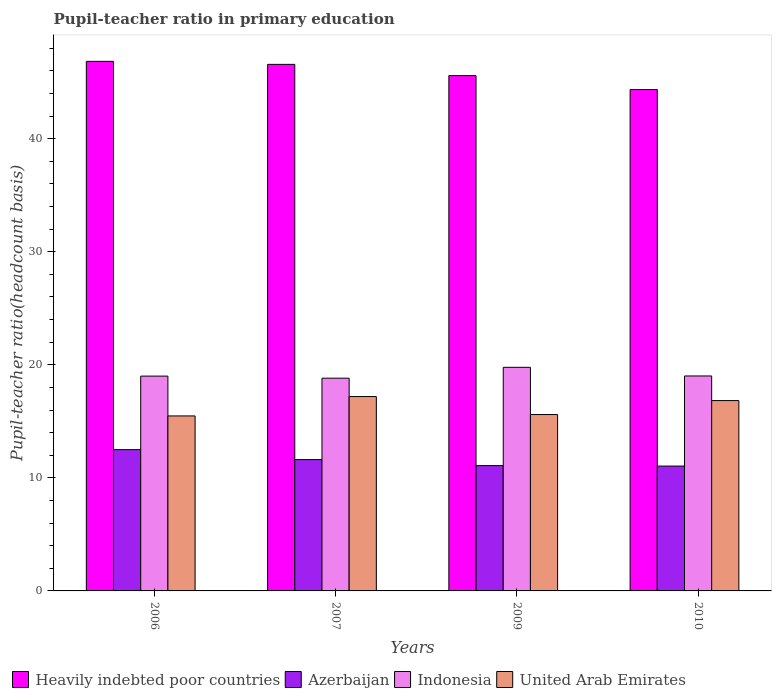How many groups of bars are there?
Provide a succinct answer. 4. Are the number of bars per tick equal to the number of legend labels?
Your answer should be very brief. Yes. In how many cases, is the number of bars for a given year not equal to the number of legend labels?
Give a very brief answer. 0. What is the pupil-teacher ratio in primary education in Azerbaijan in 2006?
Offer a very short reply. 12.5. Across all years, what is the maximum pupil-teacher ratio in primary education in Heavily indebted poor countries?
Give a very brief answer. 46.84. Across all years, what is the minimum pupil-teacher ratio in primary education in Heavily indebted poor countries?
Your answer should be compact. 44.35. In which year was the pupil-teacher ratio in primary education in Azerbaijan minimum?
Make the answer very short. 2010. What is the total pupil-teacher ratio in primary education in Azerbaijan in the graph?
Offer a terse response. 46.24. What is the difference between the pupil-teacher ratio in primary education in United Arab Emirates in 2007 and that in 2009?
Ensure brevity in your answer.  1.59. What is the difference between the pupil-teacher ratio in primary education in United Arab Emirates in 2009 and the pupil-teacher ratio in primary education in Heavily indebted poor countries in 2006?
Your answer should be very brief. -31.24. What is the average pupil-teacher ratio in primary education in Indonesia per year?
Make the answer very short. 19.15. In the year 2006, what is the difference between the pupil-teacher ratio in primary education in Indonesia and pupil-teacher ratio in primary education in Azerbaijan?
Provide a succinct answer. 6.5. What is the ratio of the pupil-teacher ratio in primary education in United Arab Emirates in 2006 to that in 2007?
Your answer should be compact. 0.9. What is the difference between the highest and the second highest pupil-teacher ratio in primary education in Heavily indebted poor countries?
Provide a short and direct response. 0.27. What is the difference between the highest and the lowest pupil-teacher ratio in primary education in United Arab Emirates?
Offer a very short reply. 1.71. Is the sum of the pupil-teacher ratio in primary education in Indonesia in 2007 and 2010 greater than the maximum pupil-teacher ratio in primary education in Heavily indebted poor countries across all years?
Give a very brief answer. No. What does the 3rd bar from the left in 2006 represents?
Provide a short and direct response. Indonesia. What does the 4th bar from the right in 2006 represents?
Give a very brief answer. Heavily indebted poor countries. Is it the case that in every year, the sum of the pupil-teacher ratio in primary education in Azerbaijan and pupil-teacher ratio in primary education in Indonesia is greater than the pupil-teacher ratio in primary education in Heavily indebted poor countries?
Ensure brevity in your answer.  No. How many bars are there?
Keep it short and to the point. 16. What is the difference between two consecutive major ticks on the Y-axis?
Provide a short and direct response. 10. Does the graph contain grids?
Make the answer very short. No. How many legend labels are there?
Your answer should be compact. 4. How are the legend labels stacked?
Offer a very short reply. Horizontal. What is the title of the graph?
Make the answer very short. Pupil-teacher ratio in primary education. Does "Mauritania" appear as one of the legend labels in the graph?
Keep it short and to the point. No. What is the label or title of the Y-axis?
Offer a very short reply. Pupil-teacher ratio(headcount basis). What is the Pupil-teacher ratio(headcount basis) of Heavily indebted poor countries in 2006?
Ensure brevity in your answer.  46.84. What is the Pupil-teacher ratio(headcount basis) of Azerbaijan in 2006?
Your answer should be very brief. 12.5. What is the Pupil-teacher ratio(headcount basis) of Indonesia in 2006?
Offer a terse response. 19. What is the Pupil-teacher ratio(headcount basis) of United Arab Emirates in 2006?
Keep it short and to the point. 15.48. What is the Pupil-teacher ratio(headcount basis) in Heavily indebted poor countries in 2007?
Offer a terse response. 46.57. What is the Pupil-teacher ratio(headcount basis) of Azerbaijan in 2007?
Your response must be concise. 11.62. What is the Pupil-teacher ratio(headcount basis) in Indonesia in 2007?
Provide a succinct answer. 18.82. What is the Pupil-teacher ratio(headcount basis) of United Arab Emirates in 2007?
Provide a succinct answer. 17.19. What is the Pupil-teacher ratio(headcount basis) of Heavily indebted poor countries in 2009?
Make the answer very short. 45.58. What is the Pupil-teacher ratio(headcount basis) of Azerbaijan in 2009?
Provide a succinct answer. 11.08. What is the Pupil-teacher ratio(headcount basis) of Indonesia in 2009?
Your answer should be very brief. 19.78. What is the Pupil-teacher ratio(headcount basis) in United Arab Emirates in 2009?
Keep it short and to the point. 15.6. What is the Pupil-teacher ratio(headcount basis) in Heavily indebted poor countries in 2010?
Make the answer very short. 44.35. What is the Pupil-teacher ratio(headcount basis) in Azerbaijan in 2010?
Provide a short and direct response. 11.04. What is the Pupil-teacher ratio(headcount basis) of Indonesia in 2010?
Make the answer very short. 19.01. What is the Pupil-teacher ratio(headcount basis) of United Arab Emirates in 2010?
Provide a succinct answer. 16.83. Across all years, what is the maximum Pupil-teacher ratio(headcount basis) of Heavily indebted poor countries?
Your answer should be compact. 46.84. Across all years, what is the maximum Pupil-teacher ratio(headcount basis) in Azerbaijan?
Provide a short and direct response. 12.5. Across all years, what is the maximum Pupil-teacher ratio(headcount basis) in Indonesia?
Keep it short and to the point. 19.78. Across all years, what is the maximum Pupil-teacher ratio(headcount basis) of United Arab Emirates?
Give a very brief answer. 17.19. Across all years, what is the minimum Pupil-teacher ratio(headcount basis) of Heavily indebted poor countries?
Provide a short and direct response. 44.35. Across all years, what is the minimum Pupil-teacher ratio(headcount basis) of Azerbaijan?
Keep it short and to the point. 11.04. Across all years, what is the minimum Pupil-teacher ratio(headcount basis) of Indonesia?
Provide a succinct answer. 18.82. Across all years, what is the minimum Pupil-teacher ratio(headcount basis) in United Arab Emirates?
Your response must be concise. 15.48. What is the total Pupil-teacher ratio(headcount basis) of Heavily indebted poor countries in the graph?
Your answer should be very brief. 183.33. What is the total Pupil-teacher ratio(headcount basis) in Azerbaijan in the graph?
Make the answer very short. 46.24. What is the total Pupil-teacher ratio(headcount basis) in Indonesia in the graph?
Offer a terse response. 76.6. What is the total Pupil-teacher ratio(headcount basis) in United Arab Emirates in the graph?
Your response must be concise. 65.1. What is the difference between the Pupil-teacher ratio(headcount basis) of Heavily indebted poor countries in 2006 and that in 2007?
Provide a succinct answer. 0.27. What is the difference between the Pupil-teacher ratio(headcount basis) of Azerbaijan in 2006 and that in 2007?
Give a very brief answer. 0.88. What is the difference between the Pupil-teacher ratio(headcount basis) of Indonesia in 2006 and that in 2007?
Make the answer very short. 0.18. What is the difference between the Pupil-teacher ratio(headcount basis) in United Arab Emirates in 2006 and that in 2007?
Make the answer very short. -1.71. What is the difference between the Pupil-teacher ratio(headcount basis) of Heavily indebted poor countries in 2006 and that in 2009?
Provide a succinct answer. 1.26. What is the difference between the Pupil-teacher ratio(headcount basis) in Azerbaijan in 2006 and that in 2009?
Offer a terse response. 1.41. What is the difference between the Pupil-teacher ratio(headcount basis) of Indonesia in 2006 and that in 2009?
Offer a very short reply. -0.78. What is the difference between the Pupil-teacher ratio(headcount basis) in United Arab Emirates in 2006 and that in 2009?
Provide a succinct answer. -0.12. What is the difference between the Pupil-teacher ratio(headcount basis) in Heavily indebted poor countries in 2006 and that in 2010?
Provide a succinct answer. 2.49. What is the difference between the Pupil-teacher ratio(headcount basis) in Azerbaijan in 2006 and that in 2010?
Offer a terse response. 1.45. What is the difference between the Pupil-teacher ratio(headcount basis) in Indonesia in 2006 and that in 2010?
Offer a very short reply. -0.01. What is the difference between the Pupil-teacher ratio(headcount basis) in United Arab Emirates in 2006 and that in 2010?
Your answer should be very brief. -1.36. What is the difference between the Pupil-teacher ratio(headcount basis) of Azerbaijan in 2007 and that in 2009?
Your answer should be very brief. 0.53. What is the difference between the Pupil-teacher ratio(headcount basis) in Indonesia in 2007 and that in 2009?
Provide a short and direct response. -0.96. What is the difference between the Pupil-teacher ratio(headcount basis) in United Arab Emirates in 2007 and that in 2009?
Offer a terse response. 1.59. What is the difference between the Pupil-teacher ratio(headcount basis) in Heavily indebted poor countries in 2007 and that in 2010?
Your answer should be very brief. 2.23. What is the difference between the Pupil-teacher ratio(headcount basis) of Azerbaijan in 2007 and that in 2010?
Provide a succinct answer. 0.57. What is the difference between the Pupil-teacher ratio(headcount basis) in Indonesia in 2007 and that in 2010?
Your answer should be compact. -0.2. What is the difference between the Pupil-teacher ratio(headcount basis) of United Arab Emirates in 2007 and that in 2010?
Provide a succinct answer. 0.36. What is the difference between the Pupil-teacher ratio(headcount basis) in Heavily indebted poor countries in 2009 and that in 2010?
Offer a very short reply. 1.23. What is the difference between the Pupil-teacher ratio(headcount basis) in Azerbaijan in 2009 and that in 2010?
Offer a very short reply. 0.04. What is the difference between the Pupil-teacher ratio(headcount basis) in Indonesia in 2009 and that in 2010?
Keep it short and to the point. 0.76. What is the difference between the Pupil-teacher ratio(headcount basis) of United Arab Emirates in 2009 and that in 2010?
Offer a very short reply. -1.23. What is the difference between the Pupil-teacher ratio(headcount basis) of Heavily indebted poor countries in 2006 and the Pupil-teacher ratio(headcount basis) of Azerbaijan in 2007?
Offer a very short reply. 35.22. What is the difference between the Pupil-teacher ratio(headcount basis) in Heavily indebted poor countries in 2006 and the Pupil-teacher ratio(headcount basis) in Indonesia in 2007?
Keep it short and to the point. 28.02. What is the difference between the Pupil-teacher ratio(headcount basis) in Heavily indebted poor countries in 2006 and the Pupil-teacher ratio(headcount basis) in United Arab Emirates in 2007?
Your answer should be very brief. 29.65. What is the difference between the Pupil-teacher ratio(headcount basis) of Azerbaijan in 2006 and the Pupil-teacher ratio(headcount basis) of Indonesia in 2007?
Give a very brief answer. -6.32. What is the difference between the Pupil-teacher ratio(headcount basis) of Azerbaijan in 2006 and the Pupil-teacher ratio(headcount basis) of United Arab Emirates in 2007?
Your answer should be very brief. -4.69. What is the difference between the Pupil-teacher ratio(headcount basis) of Indonesia in 2006 and the Pupil-teacher ratio(headcount basis) of United Arab Emirates in 2007?
Keep it short and to the point. 1.81. What is the difference between the Pupil-teacher ratio(headcount basis) of Heavily indebted poor countries in 2006 and the Pupil-teacher ratio(headcount basis) of Azerbaijan in 2009?
Provide a succinct answer. 35.75. What is the difference between the Pupil-teacher ratio(headcount basis) of Heavily indebted poor countries in 2006 and the Pupil-teacher ratio(headcount basis) of Indonesia in 2009?
Provide a short and direct response. 27.06. What is the difference between the Pupil-teacher ratio(headcount basis) of Heavily indebted poor countries in 2006 and the Pupil-teacher ratio(headcount basis) of United Arab Emirates in 2009?
Offer a terse response. 31.24. What is the difference between the Pupil-teacher ratio(headcount basis) in Azerbaijan in 2006 and the Pupil-teacher ratio(headcount basis) in Indonesia in 2009?
Give a very brief answer. -7.28. What is the difference between the Pupil-teacher ratio(headcount basis) of Azerbaijan in 2006 and the Pupil-teacher ratio(headcount basis) of United Arab Emirates in 2009?
Offer a very short reply. -3.1. What is the difference between the Pupil-teacher ratio(headcount basis) of Indonesia in 2006 and the Pupil-teacher ratio(headcount basis) of United Arab Emirates in 2009?
Ensure brevity in your answer.  3.4. What is the difference between the Pupil-teacher ratio(headcount basis) in Heavily indebted poor countries in 2006 and the Pupil-teacher ratio(headcount basis) in Azerbaijan in 2010?
Ensure brevity in your answer.  35.8. What is the difference between the Pupil-teacher ratio(headcount basis) of Heavily indebted poor countries in 2006 and the Pupil-teacher ratio(headcount basis) of Indonesia in 2010?
Ensure brevity in your answer.  27.83. What is the difference between the Pupil-teacher ratio(headcount basis) of Heavily indebted poor countries in 2006 and the Pupil-teacher ratio(headcount basis) of United Arab Emirates in 2010?
Offer a terse response. 30. What is the difference between the Pupil-teacher ratio(headcount basis) in Azerbaijan in 2006 and the Pupil-teacher ratio(headcount basis) in Indonesia in 2010?
Provide a succinct answer. -6.52. What is the difference between the Pupil-teacher ratio(headcount basis) in Azerbaijan in 2006 and the Pupil-teacher ratio(headcount basis) in United Arab Emirates in 2010?
Make the answer very short. -4.34. What is the difference between the Pupil-teacher ratio(headcount basis) of Indonesia in 2006 and the Pupil-teacher ratio(headcount basis) of United Arab Emirates in 2010?
Offer a terse response. 2.17. What is the difference between the Pupil-teacher ratio(headcount basis) of Heavily indebted poor countries in 2007 and the Pupil-teacher ratio(headcount basis) of Azerbaijan in 2009?
Your answer should be compact. 35.49. What is the difference between the Pupil-teacher ratio(headcount basis) in Heavily indebted poor countries in 2007 and the Pupil-teacher ratio(headcount basis) in Indonesia in 2009?
Offer a terse response. 26.79. What is the difference between the Pupil-teacher ratio(headcount basis) in Heavily indebted poor countries in 2007 and the Pupil-teacher ratio(headcount basis) in United Arab Emirates in 2009?
Your answer should be very brief. 30.97. What is the difference between the Pupil-teacher ratio(headcount basis) in Azerbaijan in 2007 and the Pupil-teacher ratio(headcount basis) in Indonesia in 2009?
Offer a very short reply. -8.16. What is the difference between the Pupil-teacher ratio(headcount basis) in Azerbaijan in 2007 and the Pupil-teacher ratio(headcount basis) in United Arab Emirates in 2009?
Your answer should be compact. -3.98. What is the difference between the Pupil-teacher ratio(headcount basis) of Indonesia in 2007 and the Pupil-teacher ratio(headcount basis) of United Arab Emirates in 2009?
Ensure brevity in your answer.  3.22. What is the difference between the Pupil-teacher ratio(headcount basis) of Heavily indebted poor countries in 2007 and the Pupil-teacher ratio(headcount basis) of Azerbaijan in 2010?
Your response must be concise. 35.53. What is the difference between the Pupil-teacher ratio(headcount basis) in Heavily indebted poor countries in 2007 and the Pupil-teacher ratio(headcount basis) in Indonesia in 2010?
Give a very brief answer. 27.56. What is the difference between the Pupil-teacher ratio(headcount basis) of Heavily indebted poor countries in 2007 and the Pupil-teacher ratio(headcount basis) of United Arab Emirates in 2010?
Provide a short and direct response. 29.74. What is the difference between the Pupil-teacher ratio(headcount basis) of Azerbaijan in 2007 and the Pupil-teacher ratio(headcount basis) of Indonesia in 2010?
Provide a succinct answer. -7.4. What is the difference between the Pupil-teacher ratio(headcount basis) in Azerbaijan in 2007 and the Pupil-teacher ratio(headcount basis) in United Arab Emirates in 2010?
Keep it short and to the point. -5.22. What is the difference between the Pupil-teacher ratio(headcount basis) of Indonesia in 2007 and the Pupil-teacher ratio(headcount basis) of United Arab Emirates in 2010?
Offer a very short reply. 1.98. What is the difference between the Pupil-teacher ratio(headcount basis) in Heavily indebted poor countries in 2009 and the Pupil-teacher ratio(headcount basis) in Azerbaijan in 2010?
Your answer should be compact. 34.53. What is the difference between the Pupil-teacher ratio(headcount basis) in Heavily indebted poor countries in 2009 and the Pupil-teacher ratio(headcount basis) in Indonesia in 2010?
Your response must be concise. 26.56. What is the difference between the Pupil-teacher ratio(headcount basis) in Heavily indebted poor countries in 2009 and the Pupil-teacher ratio(headcount basis) in United Arab Emirates in 2010?
Your answer should be compact. 28.74. What is the difference between the Pupil-teacher ratio(headcount basis) in Azerbaijan in 2009 and the Pupil-teacher ratio(headcount basis) in Indonesia in 2010?
Ensure brevity in your answer.  -7.93. What is the difference between the Pupil-teacher ratio(headcount basis) in Azerbaijan in 2009 and the Pupil-teacher ratio(headcount basis) in United Arab Emirates in 2010?
Provide a succinct answer. -5.75. What is the difference between the Pupil-teacher ratio(headcount basis) in Indonesia in 2009 and the Pupil-teacher ratio(headcount basis) in United Arab Emirates in 2010?
Provide a succinct answer. 2.94. What is the average Pupil-teacher ratio(headcount basis) of Heavily indebted poor countries per year?
Offer a very short reply. 45.83. What is the average Pupil-teacher ratio(headcount basis) of Azerbaijan per year?
Your response must be concise. 11.56. What is the average Pupil-teacher ratio(headcount basis) in Indonesia per year?
Offer a terse response. 19.15. What is the average Pupil-teacher ratio(headcount basis) of United Arab Emirates per year?
Your response must be concise. 16.28. In the year 2006, what is the difference between the Pupil-teacher ratio(headcount basis) in Heavily indebted poor countries and Pupil-teacher ratio(headcount basis) in Azerbaijan?
Provide a short and direct response. 34.34. In the year 2006, what is the difference between the Pupil-teacher ratio(headcount basis) in Heavily indebted poor countries and Pupil-teacher ratio(headcount basis) in Indonesia?
Offer a terse response. 27.84. In the year 2006, what is the difference between the Pupil-teacher ratio(headcount basis) in Heavily indebted poor countries and Pupil-teacher ratio(headcount basis) in United Arab Emirates?
Give a very brief answer. 31.36. In the year 2006, what is the difference between the Pupil-teacher ratio(headcount basis) of Azerbaijan and Pupil-teacher ratio(headcount basis) of Indonesia?
Give a very brief answer. -6.5. In the year 2006, what is the difference between the Pupil-teacher ratio(headcount basis) in Azerbaijan and Pupil-teacher ratio(headcount basis) in United Arab Emirates?
Ensure brevity in your answer.  -2.98. In the year 2006, what is the difference between the Pupil-teacher ratio(headcount basis) in Indonesia and Pupil-teacher ratio(headcount basis) in United Arab Emirates?
Your answer should be compact. 3.52. In the year 2007, what is the difference between the Pupil-teacher ratio(headcount basis) of Heavily indebted poor countries and Pupil-teacher ratio(headcount basis) of Azerbaijan?
Make the answer very short. 34.95. In the year 2007, what is the difference between the Pupil-teacher ratio(headcount basis) in Heavily indebted poor countries and Pupil-teacher ratio(headcount basis) in Indonesia?
Give a very brief answer. 27.75. In the year 2007, what is the difference between the Pupil-teacher ratio(headcount basis) of Heavily indebted poor countries and Pupil-teacher ratio(headcount basis) of United Arab Emirates?
Your answer should be compact. 29.38. In the year 2007, what is the difference between the Pupil-teacher ratio(headcount basis) of Azerbaijan and Pupil-teacher ratio(headcount basis) of Indonesia?
Provide a short and direct response. -7.2. In the year 2007, what is the difference between the Pupil-teacher ratio(headcount basis) in Azerbaijan and Pupil-teacher ratio(headcount basis) in United Arab Emirates?
Your response must be concise. -5.57. In the year 2007, what is the difference between the Pupil-teacher ratio(headcount basis) in Indonesia and Pupil-teacher ratio(headcount basis) in United Arab Emirates?
Make the answer very short. 1.63. In the year 2009, what is the difference between the Pupil-teacher ratio(headcount basis) of Heavily indebted poor countries and Pupil-teacher ratio(headcount basis) of Azerbaijan?
Keep it short and to the point. 34.49. In the year 2009, what is the difference between the Pupil-teacher ratio(headcount basis) of Heavily indebted poor countries and Pupil-teacher ratio(headcount basis) of Indonesia?
Your answer should be very brief. 25.8. In the year 2009, what is the difference between the Pupil-teacher ratio(headcount basis) of Heavily indebted poor countries and Pupil-teacher ratio(headcount basis) of United Arab Emirates?
Ensure brevity in your answer.  29.98. In the year 2009, what is the difference between the Pupil-teacher ratio(headcount basis) of Azerbaijan and Pupil-teacher ratio(headcount basis) of Indonesia?
Give a very brief answer. -8.69. In the year 2009, what is the difference between the Pupil-teacher ratio(headcount basis) of Azerbaijan and Pupil-teacher ratio(headcount basis) of United Arab Emirates?
Provide a short and direct response. -4.52. In the year 2009, what is the difference between the Pupil-teacher ratio(headcount basis) of Indonesia and Pupil-teacher ratio(headcount basis) of United Arab Emirates?
Your response must be concise. 4.18. In the year 2010, what is the difference between the Pupil-teacher ratio(headcount basis) in Heavily indebted poor countries and Pupil-teacher ratio(headcount basis) in Azerbaijan?
Your answer should be very brief. 33.3. In the year 2010, what is the difference between the Pupil-teacher ratio(headcount basis) of Heavily indebted poor countries and Pupil-teacher ratio(headcount basis) of Indonesia?
Offer a terse response. 25.33. In the year 2010, what is the difference between the Pupil-teacher ratio(headcount basis) of Heavily indebted poor countries and Pupil-teacher ratio(headcount basis) of United Arab Emirates?
Make the answer very short. 27.51. In the year 2010, what is the difference between the Pupil-teacher ratio(headcount basis) of Azerbaijan and Pupil-teacher ratio(headcount basis) of Indonesia?
Offer a very short reply. -7.97. In the year 2010, what is the difference between the Pupil-teacher ratio(headcount basis) of Azerbaijan and Pupil-teacher ratio(headcount basis) of United Arab Emirates?
Provide a succinct answer. -5.79. In the year 2010, what is the difference between the Pupil-teacher ratio(headcount basis) of Indonesia and Pupil-teacher ratio(headcount basis) of United Arab Emirates?
Offer a terse response. 2.18. What is the ratio of the Pupil-teacher ratio(headcount basis) of Heavily indebted poor countries in 2006 to that in 2007?
Your response must be concise. 1.01. What is the ratio of the Pupil-teacher ratio(headcount basis) in Azerbaijan in 2006 to that in 2007?
Offer a very short reply. 1.08. What is the ratio of the Pupil-teacher ratio(headcount basis) of Indonesia in 2006 to that in 2007?
Provide a short and direct response. 1.01. What is the ratio of the Pupil-teacher ratio(headcount basis) in United Arab Emirates in 2006 to that in 2007?
Keep it short and to the point. 0.9. What is the ratio of the Pupil-teacher ratio(headcount basis) of Heavily indebted poor countries in 2006 to that in 2009?
Your answer should be compact. 1.03. What is the ratio of the Pupil-teacher ratio(headcount basis) of Azerbaijan in 2006 to that in 2009?
Provide a short and direct response. 1.13. What is the ratio of the Pupil-teacher ratio(headcount basis) in Indonesia in 2006 to that in 2009?
Your answer should be very brief. 0.96. What is the ratio of the Pupil-teacher ratio(headcount basis) of Heavily indebted poor countries in 2006 to that in 2010?
Your answer should be very brief. 1.06. What is the ratio of the Pupil-teacher ratio(headcount basis) in Azerbaijan in 2006 to that in 2010?
Provide a succinct answer. 1.13. What is the ratio of the Pupil-teacher ratio(headcount basis) in United Arab Emirates in 2006 to that in 2010?
Give a very brief answer. 0.92. What is the ratio of the Pupil-teacher ratio(headcount basis) in Heavily indebted poor countries in 2007 to that in 2009?
Ensure brevity in your answer.  1.02. What is the ratio of the Pupil-teacher ratio(headcount basis) of Azerbaijan in 2007 to that in 2009?
Offer a very short reply. 1.05. What is the ratio of the Pupil-teacher ratio(headcount basis) of Indonesia in 2007 to that in 2009?
Provide a succinct answer. 0.95. What is the ratio of the Pupil-teacher ratio(headcount basis) of United Arab Emirates in 2007 to that in 2009?
Offer a terse response. 1.1. What is the ratio of the Pupil-teacher ratio(headcount basis) in Heavily indebted poor countries in 2007 to that in 2010?
Your answer should be very brief. 1.05. What is the ratio of the Pupil-teacher ratio(headcount basis) of Azerbaijan in 2007 to that in 2010?
Keep it short and to the point. 1.05. What is the ratio of the Pupil-teacher ratio(headcount basis) in United Arab Emirates in 2007 to that in 2010?
Provide a succinct answer. 1.02. What is the ratio of the Pupil-teacher ratio(headcount basis) of Heavily indebted poor countries in 2009 to that in 2010?
Your response must be concise. 1.03. What is the ratio of the Pupil-teacher ratio(headcount basis) in Indonesia in 2009 to that in 2010?
Your response must be concise. 1.04. What is the ratio of the Pupil-teacher ratio(headcount basis) in United Arab Emirates in 2009 to that in 2010?
Your answer should be very brief. 0.93. What is the difference between the highest and the second highest Pupil-teacher ratio(headcount basis) of Heavily indebted poor countries?
Offer a very short reply. 0.27. What is the difference between the highest and the second highest Pupil-teacher ratio(headcount basis) of Azerbaijan?
Provide a succinct answer. 0.88. What is the difference between the highest and the second highest Pupil-teacher ratio(headcount basis) in Indonesia?
Make the answer very short. 0.76. What is the difference between the highest and the second highest Pupil-teacher ratio(headcount basis) of United Arab Emirates?
Offer a terse response. 0.36. What is the difference between the highest and the lowest Pupil-teacher ratio(headcount basis) of Heavily indebted poor countries?
Your response must be concise. 2.49. What is the difference between the highest and the lowest Pupil-teacher ratio(headcount basis) in Azerbaijan?
Keep it short and to the point. 1.45. What is the difference between the highest and the lowest Pupil-teacher ratio(headcount basis) of Indonesia?
Make the answer very short. 0.96. What is the difference between the highest and the lowest Pupil-teacher ratio(headcount basis) in United Arab Emirates?
Offer a terse response. 1.71. 